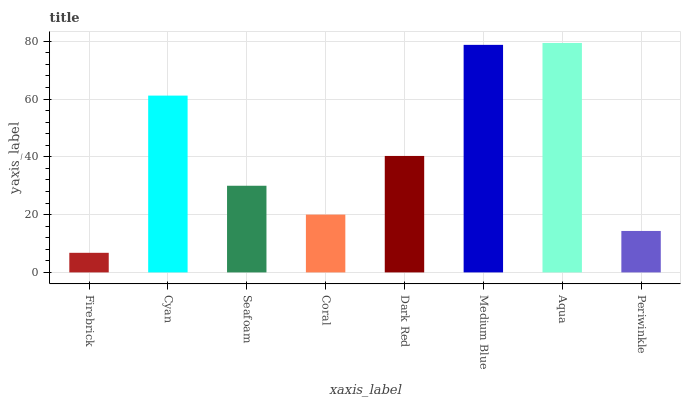Is Firebrick the minimum?
Answer yes or no. Yes. Is Aqua the maximum?
Answer yes or no. Yes. Is Cyan the minimum?
Answer yes or no. No. Is Cyan the maximum?
Answer yes or no. No. Is Cyan greater than Firebrick?
Answer yes or no. Yes. Is Firebrick less than Cyan?
Answer yes or no. Yes. Is Firebrick greater than Cyan?
Answer yes or no. No. Is Cyan less than Firebrick?
Answer yes or no. No. Is Dark Red the high median?
Answer yes or no. Yes. Is Seafoam the low median?
Answer yes or no. Yes. Is Seafoam the high median?
Answer yes or no. No. Is Firebrick the low median?
Answer yes or no. No. 